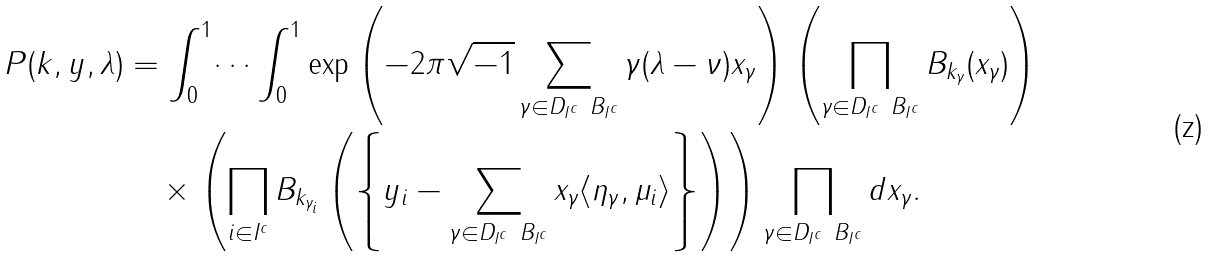Convert formula to latex. <formula><loc_0><loc_0><loc_500><loc_500>P ( k , y , \lambda ) & = \int _ { 0 } ^ { 1 } \dots \int _ { 0 } ^ { 1 } \exp \left ( - 2 \pi \sqrt { - 1 } \sum _ { \gamma \in D _ { I ^ { c } } \ B _ { I ^ { c } } } \gamma ( \lambda - \nu ) x _ { \gamma } \right ) \left ( \prod _ { \gamma \in D _ { I ^ { c } } \ B _ { I ^ { c } } } B _ { k _ { \gamma } } ( x _ { \gamma } ) \right ) \\ & \quad \times \left ( \prod _ { i \in I ^ { c } } B _ { k _ { \gamma _ { i } } } \left ( \left \{ y _ { i } - \sum _ { \gamma \in D _ { I ^ { c } } \ B _ { I ^ { c } } } x _ { \gamma } \langle \eta _ { \gamma } , \mu _ { i } \rangle \right \} \right ) \right ) \prod _ { \gamma \in D _ { I ^ { c } } \ B _ { I ^ { c } } } d x _ { \gamma } .</formula> 